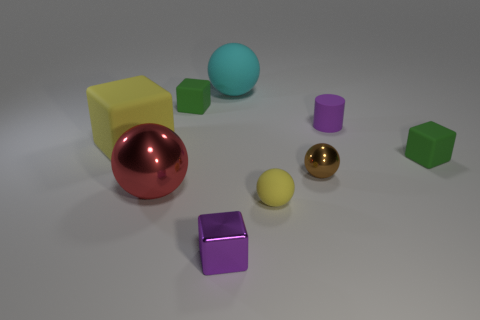What is the shape of the tiny object that is in front of the cylinder and behind the brown ball?
Provide a short and direct response. Cube. How many other things are there of the same color as the tiny rubber ball?
Ensure brevity in your answer.  1. How many things are things that are in front of the large metal ball or purple cubes?
Keep it short and to the point. 2. Do the large cube and the matte sphere that is on the right side of the cyan matte thing have the same color?
Provide a short and direct response. Yes. There is a metallic thing on the left side of the metallic object that is in front of the red object; what size is it?
Ensure brevity in your answer.  Large. How many things are either big yellow matte objects or cubes behind the large red sphere?
Your response must be concise. 3. Do the tiny green rubber thing that is behind the purple matte cylinder and the brown metallic object have the same shape?
Your answer should be very brief. No. There is a tiny green matte block that is behind the small green thing on the right side of the large cyan sphere; how many small purple shiny blocks are on the left side of it?
Make the answer very short. 0. Are there any other things that are the same shape as the tiny purple rubber object?
Give a very brief answer. No. What number of objects are either yellow cylinders or large yellow cubes?
Ensure brevity in your answer.  1. 